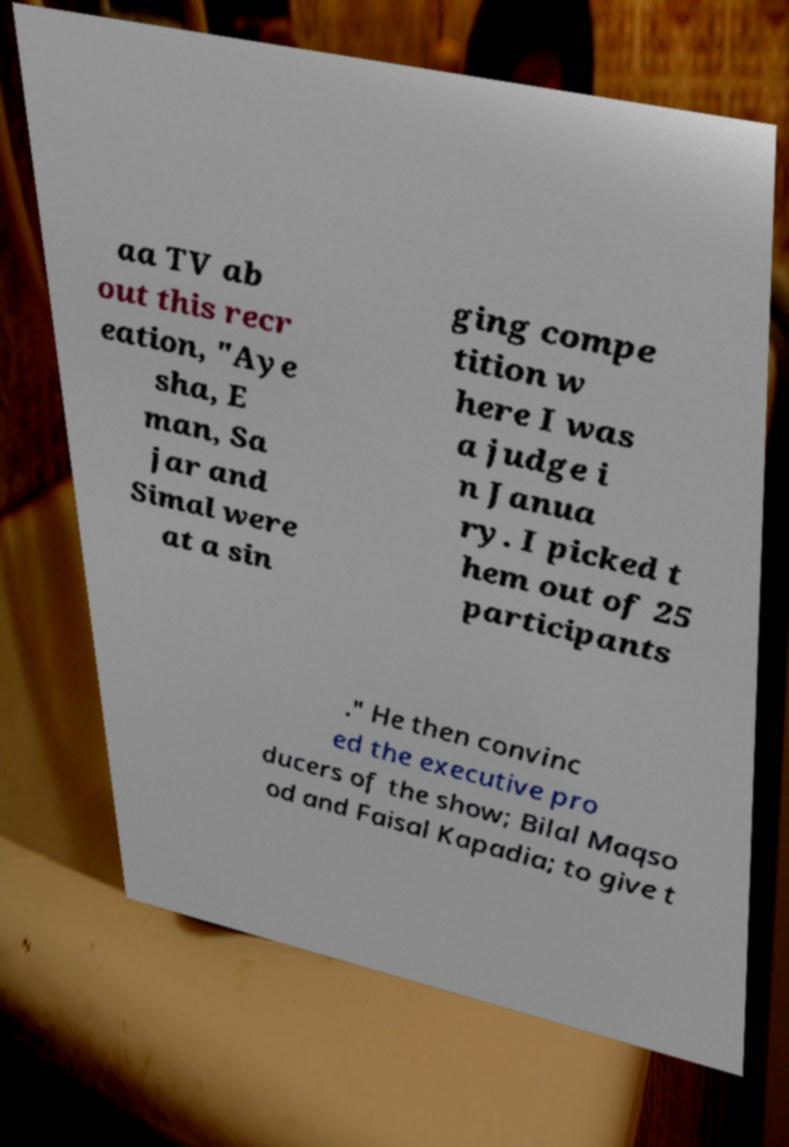Could you extract and type out the text from this image? aa TV ab out this recr eation, "Aye sha, E man, Sa jar and Simal were at a sin ging compe tition w here I was a judge i n Janua ry. I picked t hem out of 25 participants ." He then convinc ed the executive pro ducers of the show; Bilal Maqso od and Faisal Kapadia; to give t 